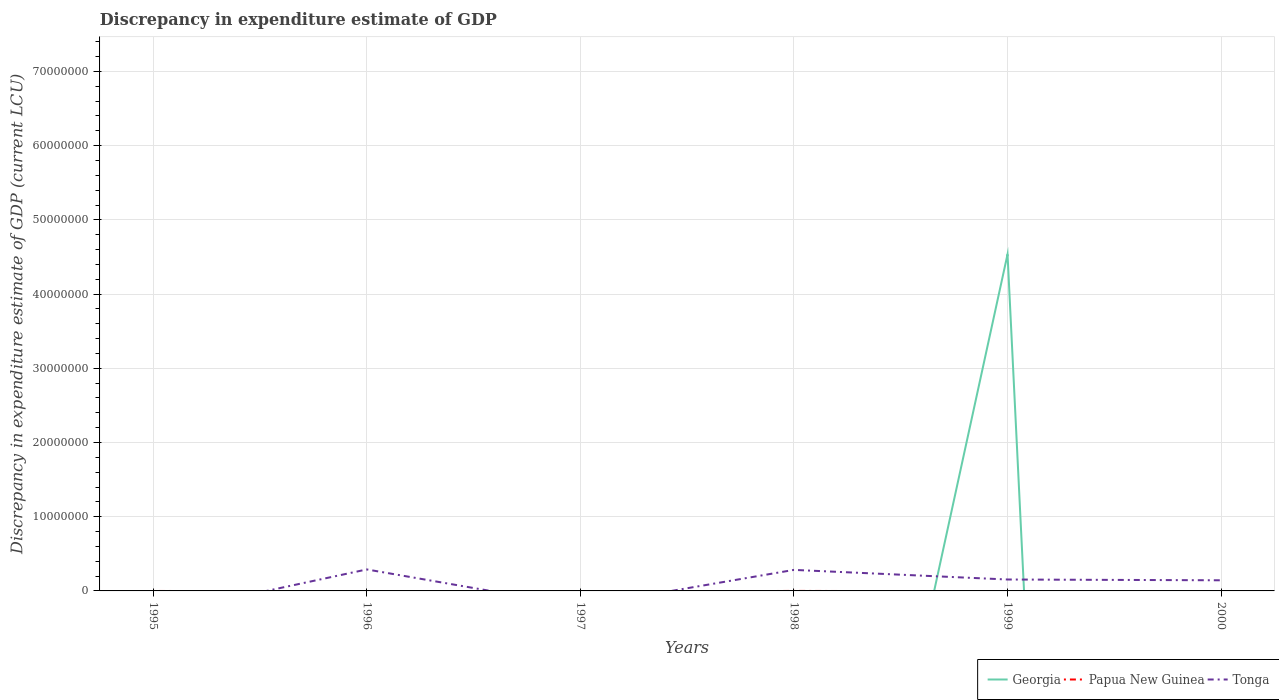How many different coloured lines are there?
Your answer should be very brief. 3. Does the line corresponding to Tonga intersect with the line corresponding to Georgia?
Your answer should be very brief. Yes. What is the total discrepancy in expenditure estimate of GDP in Tonga in the graph?
Offer a very short reply. 6.10e+04. What is the difference between the highest and the second highest discrepancy in expenditure estimate of GDP in Georgia?
Give a very brief answer. 4.54e+07. What is the difference between the highest and the lowest discrepancy in expenditure estimate of GDP in Papua New Guinea?
Your response must be concise. 1. How many lines are there?
Make the answer very short. 3. What is the difference between two consecutive major ticks on the Y-axis?
Give a very brief answer. 1.00e+07. Are the values on the major ticks of Y-axis written in scientific E-notation?
Keep it short and to the point. No. Does the graph contain any zero values?
Keep it short and to the point. Yes. Does the graph contain grids?
Make the answer very short. Yes. Where does the legend appear in the graph?
Keep it short and to the point. Bottom right. How many legend labels are there?
Ensure brevity in your answer.  3. What is the title of the graph?
Make the answer very short. Discrepancy in expenditure estimate of GDP. What is the label or title of the Y-axis?
Give a very brief answer. Discrepancy in expenditure estimate of GDP (current LCU). What is the Discrepancy in expenditure estimate of GDP (current LCU) of Papua New Guinea in 1996?
Ensure brevity in your answer.  0. What is the Discrepancy in expenditure estimate of GDP (current LCU) of Tonga in 1996?
Your response must be concise. 2.89e+06. What is the Discrepancy in expenditure estimate of GDP (current LCU) of Georgia in 1998?
Your answer should be very brief. 0. What is the Discrepancy in expenditure estimate of GDP (current LCU) in Papua New Guinea in 1998?
Offer a terse response. 1800. What is the Discrepancy in expenditure estimate of GDP (current LCU) of Tonga in 1998?
Your answer should be compact. 2.83e+06. What is the Discrepancy in expenditure estimate of GDP (current LCU) in Georgia in 1999?
Make the answer very short. 4.54e+07. What is the Discrepancy in expenditure estimate of GDP (current LCU) in Papua New Guinea in 1999?
Ensure brevity in your answer.  0. What is the Discrepancy in expenditure estimate of GDP (current LCU) of Tonga in 1999?
Provide a succinct answer. 1.54e+06. What is the Discrepancy in expenditure estimate of GDP (current LCU) of Tonga in 2000?
Your response must be concise. 1.43e+06. Across all years, what is the maximum Discrepancy in expenditure estimate of GDP (current LCU) of Georgia?
Give a very brief answer. 4.54e+07. Across all years, what is the maximum Discrepancy in expenditure estimate of GDP (current LCU) in Papua New Guinea?
Offer a terse response. 1800. Across all years, what is the maximum Discrepancy in expenditure estimate of GDP (current LCU) in Tonga?
Ensure brevity in your answer.  2.89e+06. Across all years, what is the minimum Discrepancy in expenditure estimate of GDP (current LCU) in Papua New Guinea?
Ensure brevity in your answer.  0. What is the total Discrepancy in expenditure estimate of GDP (current LCU) of Georgia in the graph?
Your answer should be compact. 4.54e+07. What is the total Discrepancy in expenditure estimate of GDP (current LCU) of Papua New Guinea in the graph?
Ensure brevity in your answer.  1800. What is the total Discrepancy in expenditure estimate of GDP (current LCU) of Tonga in the graph?
Provide a short and direct response. 8.70e+06. What is the difference between the Discrepancy in expenditure estimate of GDP (current LCU) of Georgia in 1995 and that in 1999?
Offer a very short reply. -4.54e+07. What is the difference between the Discrepancy in expenditure estimate of GDP (current LCU) of Tonga in 1996 and that in 1998?
Your answer should be compact. 6.10e+04. What is the difference between the Discrepancy in expenditure estimate of GDP (current LCU) in Tonga in 1996 and that in 1999?
Make the answer very short. 1.36e+06. What is the difference between the Discrepancy in expenditure estimate of GDP (current LCU) in Tonga in 1996 and that in 2000?
Ensure brevity in your answer.  1.46e+06. What is the difference between the Discrepancy in expenditure estimate of GDP (current LCU) of Tonga in 1998 and that in 1999?
Give a very brief answer. 1.30e+06. What is the difference between the Discrepancy in expenditure estimate of GDP (current LCU) of Tonga in 1998 and that in 2000?
Your answer should be very brief. 1.40e+06. What is the difference between the Discrepancy in expenditure estimate of GDP (current LCU) in Tonga in 1999 and that in 2000?
Your answer should be very brief. 1.06e+05. What is the difference between the Discrepancy in expenditure estimate of GDP (current LCU) of Georgia in 1995 and the Discrepancy in expenditure estimate of GDP (current LCU) of Tonga in 1996?
Ensure brevity in your answer.  -2.89e+06. What is the difference between the Discrepancy in expenditure estimate of GDP (current LCU) in Georgia in 1995 and the Discrepancy in expenditure estimate of GDP (current LCU) in Papua New Guinea in 1998?
Ensure brevity in your answer.  -1752. What is the difference between the Discrepancy in expenditure estimate of GDP (current LCU) of Georgia in 1995 and the Discrepancy in expenditure estimate of GDP (current LCU) of Tonga in 1998?
Ensure brevity in your answer.  -2.83e+06. What is the difference between the Discrepancy in expenditure estimate of GDP (current LCU) of Georgia in 1995 and the Discrepancy in expenditure estimate of GDP (current LCU) of Tonga in 1999?
Provide a succinct answer. -1.54e+06. What is the difference between the Discrepancy in expenditure estimate of GDP (current LCU) in Georgia in 1995 and the Discrepancy in expenditure estimate of GDP (current LCU) in Tonga in 2000?
Give a very brief answer. -1.43e+06. What is the difference between the Discrepancy in expenditure estimate of GDP (current LCU) in Papua New Guinea in 1998 and the Discrepancy in expenditure estimate of GDP (current LCU) in Tonga in 1999?
Make the answer very short. -1.54e+06. What is the difference between the Discrepancy in expenditure estimate of GDP (current LCU) in Papua New Guinea in 1998 and the Discrepancy in expenditure estimate of GDP (current LCU) in Tonga in 2000?
Offer a terse response. -1.43e+06. What is the difference between the Discrepancy in expenditure estimate of GDP (current LCU) of Georgia in 1999 and the Discrepancy in expenditure estimate of GDP (current LCU) of Tonga in 2000?
Offer a very short reply. 4.39e+07. What is the average Discrepancy in expenditure estimate of GDP (current LCU) in Georgia per year?
Offer a very short reply. 7.56e+06. What is the average Discrepancy in expenditure estimate of GDP (current LCU) in Papua New Guinea per year?
Your response must be concise. 300. What is the average Discrepancy in expenditure estimate of GDP (current LCU) of Tonga per year?
Provide a succinct answer. 1.45e+06. In the year 1998, what is the difference between the Discrepancy in expenditure estimate of GDP (current LCU) of Papua New Guinea and Discrepancy in expenditure estimate of GDP (current LCU) of Tonga?
Keep it short and to the point. -2.83e+06. In the year 1999, what is the difference between the Discrepancy in expenditure estimate of GDP (current LCU) in Georgia and Discrepancy in expenditure estimate of GDP (current LCU) in Tonga?
Keep it short and to the point. 4.38e+07. What is the ratio of the Discrepancy in expenditure estimate of GDP (current LCU) of Georgia in 1995 to that in 1999?
Provide a short and direct response. 0. What is the ratio of the Discrepancy in expenditure estimate of GDP (current LCU) of Tonga in 1996 to that in 1998?
Give a very brief answer. 1.02. What is the ratio of the Discrepancy in expenditure estimate of GDP (current LCU) in Tonga in 1996 to that in 1999?
Provide a short and direct response. 1.88. What is the ratio of the Discrepancy in expenditure estimate of GDP (current LCU) of Tonga in 1996 to that in 2000?
Make the answer very short. 2.02. What is the ratio of the Discrepancy in expenditure estimate of GDP (current LCU) of Tonga in 1998 to that in 1999?
Provide a succinct answer. 1.84. What is the ratio of the Discrepancy in expenditure estimate of GDP (current LCU) in Tonga in 1998 to that in 2000?
Your response must be concise. 1.98. What is the ratio of the Discrepancy in expenditure estimate of GDP (current LCU) in Tonga in 1999 to that in 2000?
Keep it short and to the point. 1.07. What is the difference between the highest and the second highest Discrepancy in expenditure estimate of GDP (current LCU) in Tonga?
Provide a succinct answer. 6.10e+04. What is the difference between the highest and the lowest Discrepancy in expenditure estimate of GDP (current LCU) of Georgia?
Give a very brief answer. 4.54e+07. What is the difference between the highest and the lowest Discrepancy in expenditure estimate of GDP (current LCU) of Papua New Guinea?
Your answer should be compact. 1800. What is the difference between the highest and the lowest Discrepancy in expenditure estimate of GDP (current LCU) of Tonga?
Your answer should be compact. 2.89e+06. 